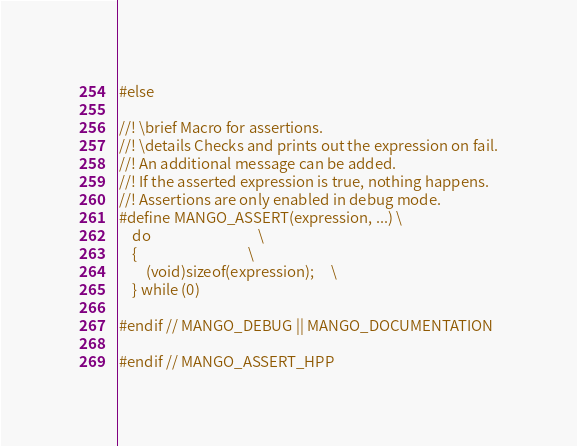<code> <loc_0><loc_0><loc_500><loc_500><_C++_>
#else

//! \brief Macro for assertions.
//! \details Checks and prints out the expression on fail.
//! An additional message can be added.
//! If the asserted expression is true, nothing happens.
//! Assertions are only enabled in debug mode.
#define MANGO_ASSERT(expression, ...) \
    do                                \
    {                                 \
        (void)sizeof(expression);     \
    } while (0)

#endif // MANGO_DEBUG || MANGO_DOCUMENTATION

#endif // MANGO_ASSERT_HPP
</code> 